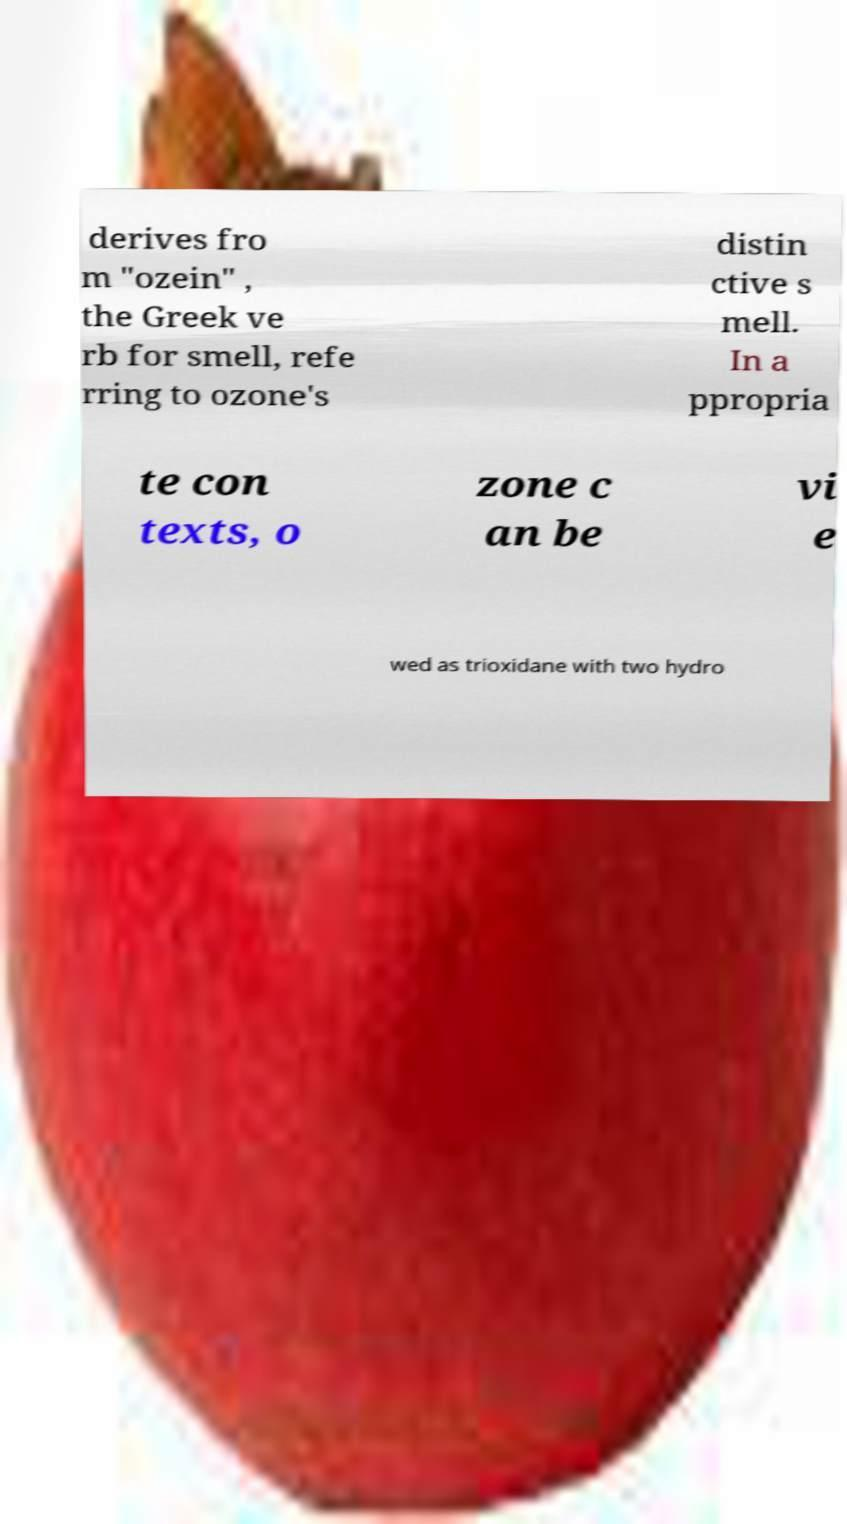Can you read and provide the text displayed in the image?This photo seems to have some interesting text. Can you extract and type it out for me? derives fro m "ozein" , the Greek ve rb for smell, refe rring to ozone's distin ctive s mell. In a ppropria te con texts, o zone c an be vi e wed as trioxidane with two hydro 